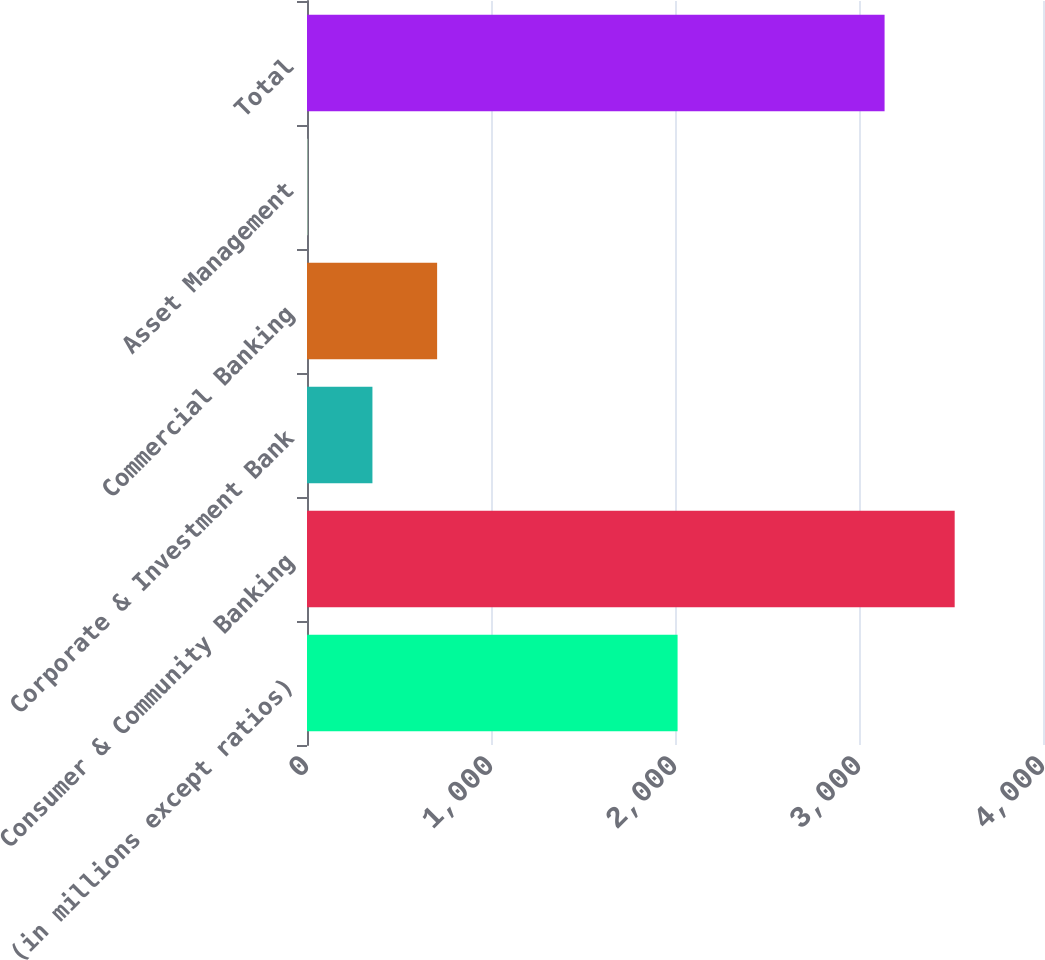<chart> <loc_0><loc_0><loc_500><loc_500><bar_chart><fcel>(in millions except ratios)<fcel>Consumer & Community Banking<fcel>Corporate & Investment Bank<fcel>Commercial Banking<fcel>Asset Management<fcel>Total<nl><fcel>2014<fcel>3520<fcel>355.6<fcel>707.2<fcel>4<fcel>3139<nl></chart> 